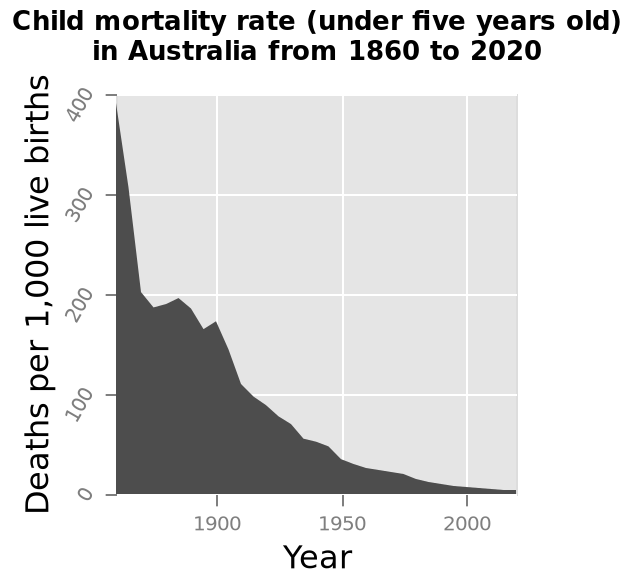<image>
What was the trend in child mortality in Australia between 1860 and 2020?  Child mortality in Australia has fallen sharply between 1860 and 2020. How is the child mortality rate represented in the chart for Australia? The child mortality rate is represented by an area chart. Has child mortality reached a plateau in recent years in Australia? Yes, child mortality has almost leveled off between the year 2000 and 2020. please describe the details of the chart Child mortality rate (under five years old) in Australia from 1860 to 2020 is a area chart. The x-axis measures Year with linear scale from 1900 to 2000 while the y-axis shows Deaths per 1,000 live births on linear scale of range 0 to 400. When did the steepest decline in child mortality occur in Australia?  The steepest decline in child mortality in Australia occurred between 1860 and 1950. How has child mortality declined after 1950? After 1950, there has been a more gradual decline in child mortality. Has child mortality significantly increased between the year 2000 and 2020? No.Yes, child mortality has almost leveled off between the year 2000 and 2020. 